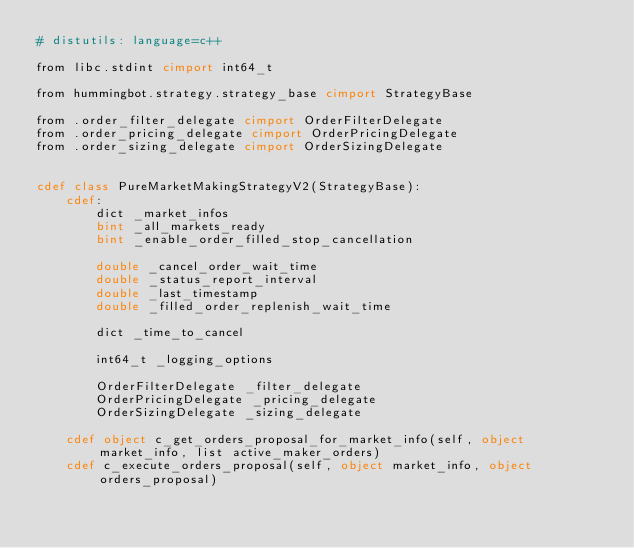<code> <loc_0><loc_0><loc_500><loc_500><_Cython_># distutils: language=c++

from libc.stdint cimport int64_t

from hummingbot.strategy.strategy_base cimport StrategyBase

from .order_filter_delegate cimport OrderFilterDelegate
from .order_pricing_delegate cimport OrderPricingDelegate
from .order_sizing_delegate cimport OrderSizingDelegate


cdef class PureMarketMakingStrategyV2(StrategyBase):
    cdef:
        dict _market_infos
        bint _all_markets_ready
        bint _enable_order_filled_stop_cancellation

        double _cancel_order_wait_time
        double _status_report_interval
        double _last_timestamp
        double _filled_order_replenish_wait_time

        dict _time_to_cancel

        int64_t _logging_options

        OrderFilterDelegate _filter_delegate
        OrderPricingDelegate _pricing_delegate
        OrderSizingDelegate _sizing_delegate

    cdef object c_get_orders_proposal_for_market_info(self, object market_info, list active_maker_orders)
    cdef c_execute_orders_proposal(self, object market_info, object orders_proposal)
</code> 